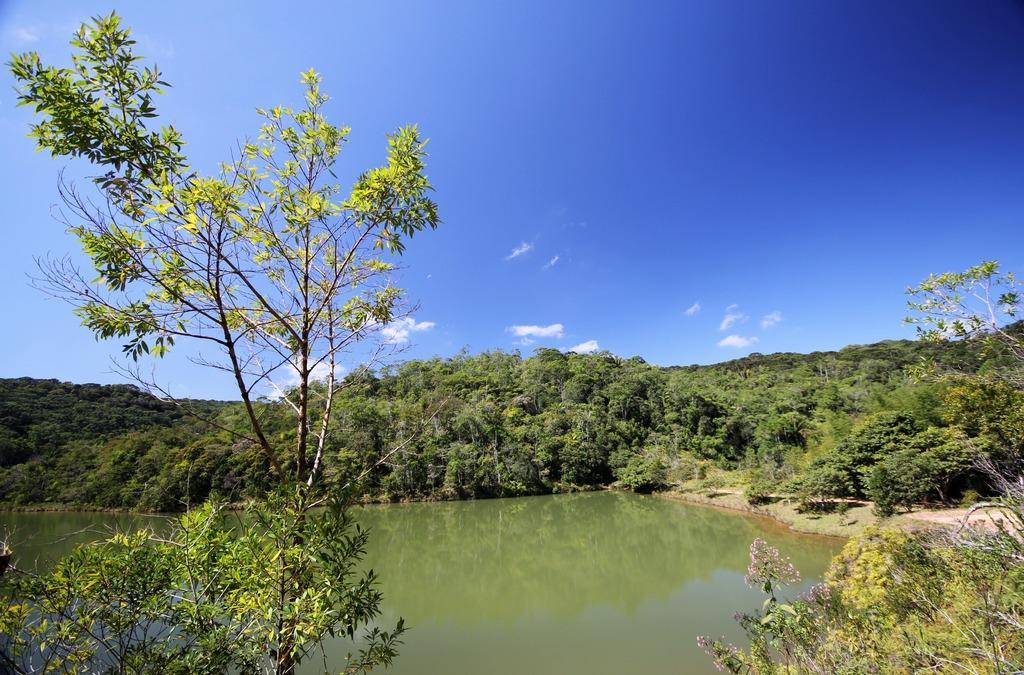Describe this image in one or two sentences. In this picture we can see the reflections of a few things on the water. We can see plants and trees. We can see the clouds in the sky. 